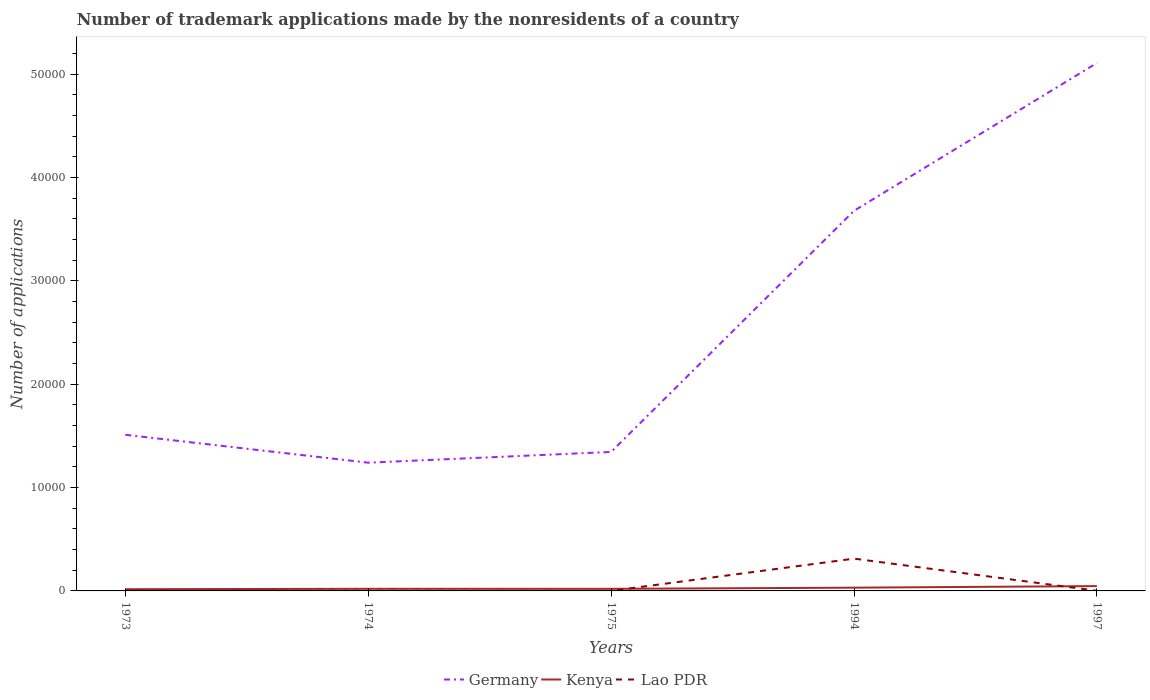Does the line corresponding to Lao PDR intersect with the line corresponding to Kenya?
Ensure brevity in your answer.  Yes. Is the number of lines equal to the number of legend labels?
Your answer should be very brief. Yes. Across all years, what is the maximum number of trademark applications made by the nonresidents in Kenya?
Your answer should be compact. 165. What is the total number of trademark applications made by the nonresidents in Germany in the graph?
Offer a very short reply. 2699. What is the difference between the highest and the second highest number of trademark applications made by the nonresidents in Kenya?
Offer a terse response. 302. How many lines are there?
Provide a short and direct response. 3. What is the difference between two consecutive major ticks on the Y-axis?
Your answer should be very brief. 10000. Are the values on the major ticks of Y-axis written in scientific E-notation?
Provide a short and direct response. No. Does the graph contain any zero values?
Your response must be concise. No. Does the graph contain grids?
Make the answer very short. No. Where does the legend appear in the graph?
Your answer should be compact. Bottom center. What is the title of the graph?
Offer a terse response. Number of trademark applications made by the nonresidents of a country. Does "Mauritania" appear as one of the legend labels in the graph?
Make the answer very short. No. What is the label or title of the X-axis?
Your answer should be very brief. Years. What is the label or title of the Y-axis?
Offer a very short reply. Number of applications. What is the Number of applications in Germany in 1973?
Make the answer very short. 1.51e+04. What is the Number of applications of Kenya in 1973?
Provide a short and direct response. 165. What is the Number of applications in Lao PDR in 1973?
Offer a terse response. 23. What is the Number of applications of Germany in 1974?
Your answer should be very brief. 1.24e+04. What is the Number of applications in Kenya in 1974?
Your response must be concise. 205. What is the Number of applications of Lao PDR in 1974?
Ensure brevity in your answer.  14. What is the Number of applications of Germany in 1975?
Offer a very short reply. 1.34e+04. What is the Number of applications of Kenya in 1975?
Offer a very short reply. 203. What is the Number of applications of Lao PDR in 1975?
Ensure brevity in your answer.  5. What is the Number of applications of Germany in 1994?
Give a very brief answer. 3.68e+04. What is the Number of applications in Kenya in 1994?
Make the answer very short. 314. What is the Number of applications of Lao PDR in 1994?
Ensure brevity in your answer.  3124. What is the Number of applications of Germany in 1997?
Your answer should be very brief. 5.11e+04. What is the Number of applications in Kenya in 1997?
Keep it short and to the point. 467. Across all years, what is the maximum Number of applications in Germany?
Give a very brief answer. 5.11e+04. Across all years, what is the maximum Number of applications in Kenya?
Provide a short and direct response. 467. Across all years, what is the maximum Number of applications in Lao PDR?
Your answer should be compact. 3124. Across all years, what is the minimum Number of applications in Germany?
Your answer should be very brief. 1.24e+04. Across all years, what is the minimum Number of applications of Kenya?
Offer a terse response. 165. Across all years, what is the minimum Number of applications of Lao PDR?
Your answer should be very brief. 5. What is the total Number of applications in Germany in the graph?
Your answer should be compact. 1.29e+05. What is the total Number of applications of Kenya in the graph?
Offer a terse response. 1354. What is the total Number of applications of Lao PDR in the graph?
Your response must be concise. 3179. What is the difference between the Number of applications of Germany in 1973 and that in 1974?
Ensure brevity in your answer.  2699. What is the difference between the Number of applications in Kenya in 1973 and that in 1974?
Ensure brevity in your answer.  -40. What is the difference between the Number of applications of Lao PDR in 1973 and that in 1974?
Your response must be concise. 9. What is the difference between the Number of applications of Germany in 1973 and that in 1975?
Your answer should be compact. 1659. What is the difference between the Number of applications of Kenya in 1973 and that in 1975?
Give a very brief answer. -38. What is the difference between the Number of applications in Lao PDR in 1973 and that in 1975?
Provide a short and direct response. 18. What is the difference between the Number of applications of Germany in 1973 and that in 1994?
Offer a very short reply. -2.17e+04. What is the difference between the Number of applications of Kenya in 1973 and that in 1994?
Make the answer very short. -149. What is the difference between the Number of applications in Lao PDR in 1973 and that in 1994?
Your response must be concise. -3101. What is the difference between the Number of applications in Germany in 1973 and that in 1997?
Make the answer very short. -3.60e+04. What is the difference between the Number of applications in Kenya in 1973 and that in 1997?
Make the answer very short. -302. What is the difference between the Number of applications in Lao PDR in 1973 and that in 1997?
Provide a succinct answer. 10. What is the difference between the Number of applications of Germany in 1974 and that in 1975?
Offer a terse response. -1040. What is the difference between the Number of applications of Lao PDR in 1974 and that in 1975?
Your response must be concise. 9. What is the difference between the Number of applications of Germany in 1974 and that in 1994?
Provide a succinct answer. -2.44e+04. What is the difference between the Number of applications in Kenya in 1974 and that in 1994?
Make the answer very short. -109. What is the difference between the Number of applications in Lao PDR in 1974 and that in 1994?
Give a very brief answer. -3110. What is the difference between the Number of applications of Germany in 1974 and that in 1997?
Provide a succinct answer. -3.87e+04. What is the difference between the Number of applications of Kenya in 1974 and that in 1997?
Offer a very short reply. -262. What is the difference between the Number of applications of Lao PDR in 1974 and that in 1997?
Your response must be concise. 1. What is the difference between the Number of applications in Germany in 1975 and that in 1994?
Ensure brevity in your answer.  -2.33e+04. What is the difference between the Number of applications of Kenya in 1975 and that in 1994?
Make the answer very short. -111. What is the difference between the Number of applications in Lao PDR in 1975 and that in 1994?
Provide a succinct answer. -3119. What is the difference between the Number of applications of Germany in 1975 and that in 1997?
Provide a succinct answer. -3.76e+04. What is the difference between the Number of applications of Kenya in 1975 and that in 1997?
Your answer should be very brief. -264. What is the difference between the Number of applications of Lao PDR in 1975 and that in 1997?
Ensure brevity in your answer.  -8. What is the difference between the Number of applications of Germany in 1994 and that in 1997?
Offer a very short reply. -1.43e+04. What is the difference between the Number of applications in Kenya in 1994 and that in 1997?
Provide a succinct answer. -153. What is the difference between the Number of applications of Lao PDR in 1994 and that in 1997?
Your answer should be very brief. 3111. What is the difference between the Number of applications of Germany in 1973 and the Number of applications of Kenya in 1974?
Provide a succinct answer. 1.49e+04. What is the difference between the Number of applications in Germany in 1973 and the Number of applications in Lao PDR in 1974?
Keep it short and to the point. 1.51e+04. What is the difference between the Number of applications in Kenya in 1973 and the Number of applications in Lao PDR in 1974?
Give a very brief answer. 151. What is the difference between the Number of applications of Germany in 1973 and the Number of applications of Kenya in 1975?
Your answer should be compact. 1.49e+04. What is the difference between the Number of applications of Germany in 1973 and the Number of applications of Lao PDR in 1975?
Offer a very short reply. 1.51e+04. What is the difference between the Number of applications in Kenya in 1973 and the Number of applications in Lao PDR in 1975?
Make the answer very short. 160. What is the difference between the Number of applications of Germany in 1973 and the Number of applications of Kenya in 1994?
Keep it short and to the point. 1.48e+04. What is the difference between the Number of applications in Germany in 1973 and the Number of applications in Lao PDR in 1994?
Offer a very short reply. 1.20e+04. What is the difference between the Number of applications of Kenya in 1973 and the Number of applications of Lao PDR in 1994?
Your answer should be compact. -2959. What is the difference between the Number of applications of Germany in 1973 and the Number of applications of Kenya in 1997?
Your answer should be very brief. 1.46e+04. What is the difference between the Number of applications of Germany in 1973 and the Number of applications of Lao PDR in 1997?
Your answer should be compact. 1.51e+04. What is the difference between the Number of applications of Kenya in 1973 and the Number of applications of Lao PDR in 1997?
Give a very brief answer. 152. What is the difference between the Number of applications in Germany in 1974 and the Number of applications in Kenya in 1975?
Offer a terse response. 1.22e+04. What is the difference between the Number of applications of Germany in 1974 and the Number of applications of Lao PDR in 1975?
Provide a short and direct response. 1.24e+04. What is the difference between the Number of applications of Germany in 1974 and the Number of applications of Kenya in 1994?
Make the answer very short. 1.21e+04. What is the difference between the Number of applications of Germany in 1974 and the Number of applications of Lao PDR in 1994?
Offer a very short reply. 9283. What is the difference between the Number of applications of Kenya in 1974 and the Number of applications of Lao PDR in 1994?
Provide a short and direct response. -2919. What is the difference between the Number of applications in Germany in 1974 and the Number of applications in Kenya in 1997?
Offer a very short reply. 1.19e+04. What is the difference between the Number of applications of Germany in 1974 and the Number of applications of Lao PDR in 1997?
Provide a succinct answer. 1.24e+04. What is the difference between the Number of applications of Kenya in 1974 and the Number of applications of Lao PDR in 1997?
Your response must be concise. 192. What is the difference between the Number of applications of Germany in 1975 and the Number of applications of Kenya in 1994?
Keep it short and to the point. 1.31e+04. What is the difference between the Number of applications in Germany in 1975 and the Number of applications in Lao PDR in 1994?
Ensure brevity in your answer.  1.03e+04. What is the difference between the Number of applications in Kenya in 1975 and the Number of applications in Lao PDR in 1994?
Provide a succinct answer. -2921. What is the difference between the Number of applications in Germany in 1975 and the Number of applications in Kenya in 1997?
Keep it short and to the point. 1.30e+04. What is the difference between the Number of applications in Germany in 1975 and the Number of applications in Lao PDR in 1997?
Ensure brevity in your answer.  1.34e+04. What is the difference between the Number of applications of Kenya in 1975 and the Number of applications of Lao PDR in 1997?
Ensure brevity in your answer.  190. What is the difference between the Number of applications in Germany in 1994 and the Number of applications in Kenya in 1997?
Keep it short and to the point. 3.63e+04. What is the difference between the Number of applications of Germany in 1994 and the Number of applications of Lao PDR in 1997?
Give a very brief answer. 3.68e+04. What is the difference between the Number of applications in Kenya in 1994 and the Number of applications in Lao PDR in 1997?
Offer a terse response. 301. What is the average Number of applications in Germany per year?
Your answer should be compact. 2.58e+04. What is the average Number of applications in Kenya per year?
Make the answer very short. 270.8. What is the average Number of applications in Lao PDR per year?
Provide a succinct answer. 635.8. In the year 1973, what is the difference between the Number of applications of Germany and Number of applications of Kenya?
Give a very brief answer. 1.49e+04. In the year 1973, what is the difference between the Number of applications of Germany and Number of applications of Lao PDR?
Give a very brief answer. 1.51e+04. In the year 1973, what is the difference between the Number of applications in Kenya and Number of applications in Lao PDR?
Your answer should be very brief. 142. In the year 1974, what is the difference between the Number of applications of Germany and Number of applications of Kenya?
Your answer should be very brief. 1.22e+04. In the year 1974, what is the difference between the Number of applications of Germany and Number of applications of Lao PDR?
Offer a terse response. 1.24e+04. In the year 1974, what is the difference between the Number of applications in Kenya and Number of applications in Lao PDR?
Offer a very short reply. 191. In the year 1975, what is the difference between the Number of applications in Germany and Number of applications in Kenya?
Give a very brief answer. 1.32e+04. In the year 1975, what is the difference between the Number of applications of Germany and Number of applications of Lao PDR?
Your response must be concise. 1.34e+04. In the year 1975, what is the difference between the Number of applications of Kenya and Number of applications of Lao PDR?
Keep it short and to the point. 198. In the year 1994, what is the difference between the Number of applications of Germany and Number of applications of Kenya?
Your response must be concise. 3.65e+04. In the year 1994, what is the difference between the Number of applications of Germany and Number of applications of Lao PDR?
Offer a terse response. 3.37e+04. In the year 1994, what is the difference between the Number of applications in Kenya and Number of applications in Lao PDR?
Keep it short and to the point. -2810. In the year 1997, what is the difference between the Number of applications of Germany and Number of applications of Kenya?
Your answer should be compact. 5.06e+04. In the year 1997, what is the difference between the Number of applications of Germany and Number of applications of Lao PDR?
Your answer should be compact. 5.11e+04. In the year 1997, what is the difference between the Number of applications in Kenya and Number of applications in Lao PDR?
Your answer should be compact. 454. What is the ratio of the Number of applications of Germany in 1973 to that in 1974?
Provide a short and direct response. 1.22. What is the ratio of the Number of applications of Kenya in 1973 to that in 1974?
Your answer should be very brief. 0.8. What is the ratio of the Number of applications in Lao PDR in 1973 to that in 1974?
Your response must be concise. 1.64. What is the ratio of the Number of applications in Germany in 1973 to that in 1975?
Make the answer very short. 1.12. What is the ratio of the Number of applications of Kenya in 1973 to that in 1975?
Provide a succinct answer. 0.81. What is the ratio of the Number of applications in Germany in 1973 to that in 1994?
Keep it short and to the point. 0.41. What is the ratio of the Number of applications in Kenya in 1973 to that in 1994?
Make the answer very short. 0.53. What is the ratio of the Number of applications in Lao PDR in 1973 to that in 1994?
Provide a succinct answer. 0.01. What is the ratio of the Number of applications of Germany in 1973 to that in 1997?
Keep it short and to the point. 0.3. What is the ratio of the Number of applications in Kenya in 1973 to that in 1997?
Make the answer very short. 0.35. What is the ratio of the Number of applications in Lao PDR in 1973 to that in 1997?
Offer a terse response. 1.77. What is the ratio of the Number of applications in Germany in 1974 to that in 1975?
Keep it short and to the point. 0.92. What is the ratio of the Number of applications in Kenya in 1974 to that in 1975?
Give a very brief answer. 1.01. What is the ratio of the Number of applications of Germany in 1974 to that in 1994?
Your answer should be very brief. 0.34. What is the ratio of the Number of applications in Kenya in 1974 to that in 1994?
Provide a succinct answer. 0.65. What is the ratio of the Number of applications of Lao PDR in 1974 to that in 1994?
Your response must be concise. 0. What is the ratio of the Number of applications of Germany in 1974 to that in 1997?
Ensure brevity in your answer.  0.24. What is the ratio of the Number of applications of Kenya in 1974 to that in 1997?
Provide a succinct answer. 0.44. What is the ratio of the Number of applications of Germany in 1975 to that in 1994?
Make the answer very short. 0.37. What is the ratio of the Number of applications of Kenya in 1975 to that in 1994?
Give a very brief answer. 0.65. What is the ratio of the Number of applications of Lao PDR in 1975 to that in 1994?
Your answer should be very brief. 0. What is the ratio of the Number of applications in Germany in 1975 to that in 1997?
Your response must be concise. 0.26. What is the ratio of the Number of applications of Kenya in 1975 to that in 1997?
Your answer should be very brief. 0.43. What is the ratio of the Number of applications in Lao PDR in 1975 to that in 1997?
Provide a short and direct response. 0.38. What is the ratio of the Number of applications of Germany in 1994 to that in 1997?
Provide a succinct answer. 0.72. What is the ratio of the Number of applications of Kenya in 1994 to that in 1997?
Provide a succinct answer. 0.67. What is the ratio of the Number of applications of Lao PDR in 1994 to that in 1997?
Your answer should be very brief. 240.31. What is the difference between the highest and the second highest Number of applications in Germany?
Your answer should be compact. 1.43e+04. What is the difference between the highest and the second highest Number of applications in Kenya?
Provide a succinct answer. 153. What is the difference between the highest and the second highest Number of applications of Lao PDR?
Give a very brief answer. 3101. What is the difference between the highest and the lowest Number of applications in Germany?
Give a very brief answer. 3.87e+04. What is the difference between the highest and the lowest Number of applications in Kenya?
Your response must be concise. 302. What is the difference between the highest and the lowest Number of applications of Lao PDR?
Offer a terse response. 3119. 